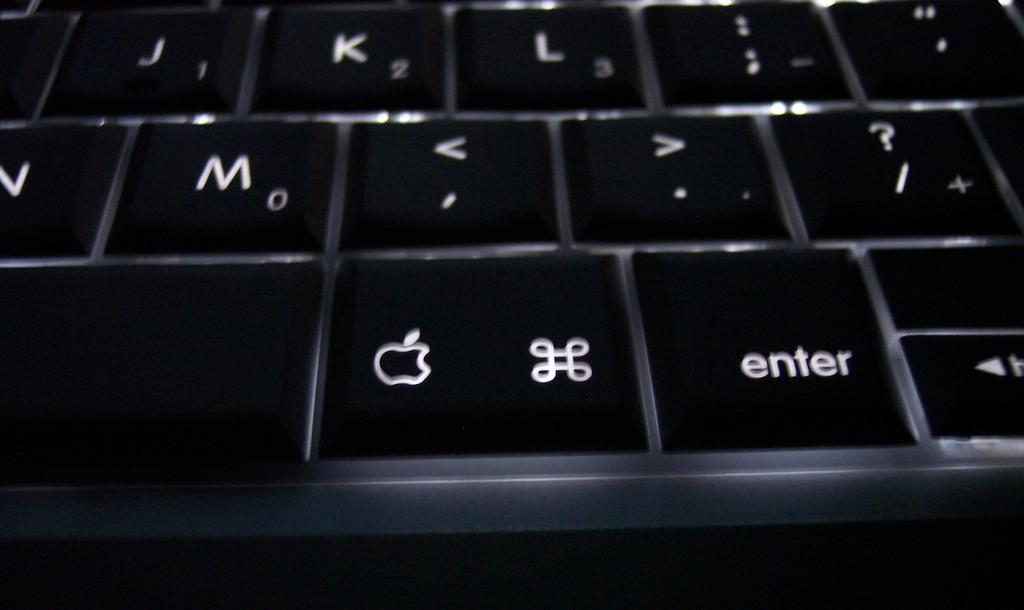Describe this image in one or two sentences. In this image we can see a keyboard with some letters and symbols on it. 